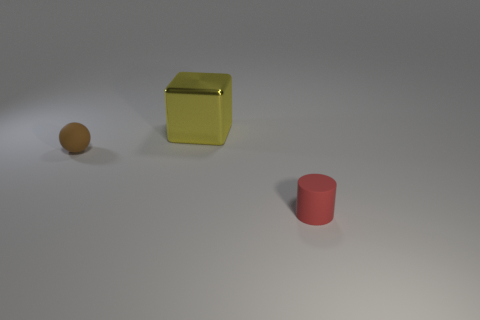Add 1 green matte cylinders. How many objects exist? 4 Add 2 metallic things. How many metallic things are left? 3 Add 3 small matte objects. How many small matte objects exist? 5 Subtract 0 brown cubes. How many objects are left? 3 Subtract all spheres. How many objects are left? 2 Subtract all brown spheres. Subtract all small brown spheres. How many objects are left? 1 